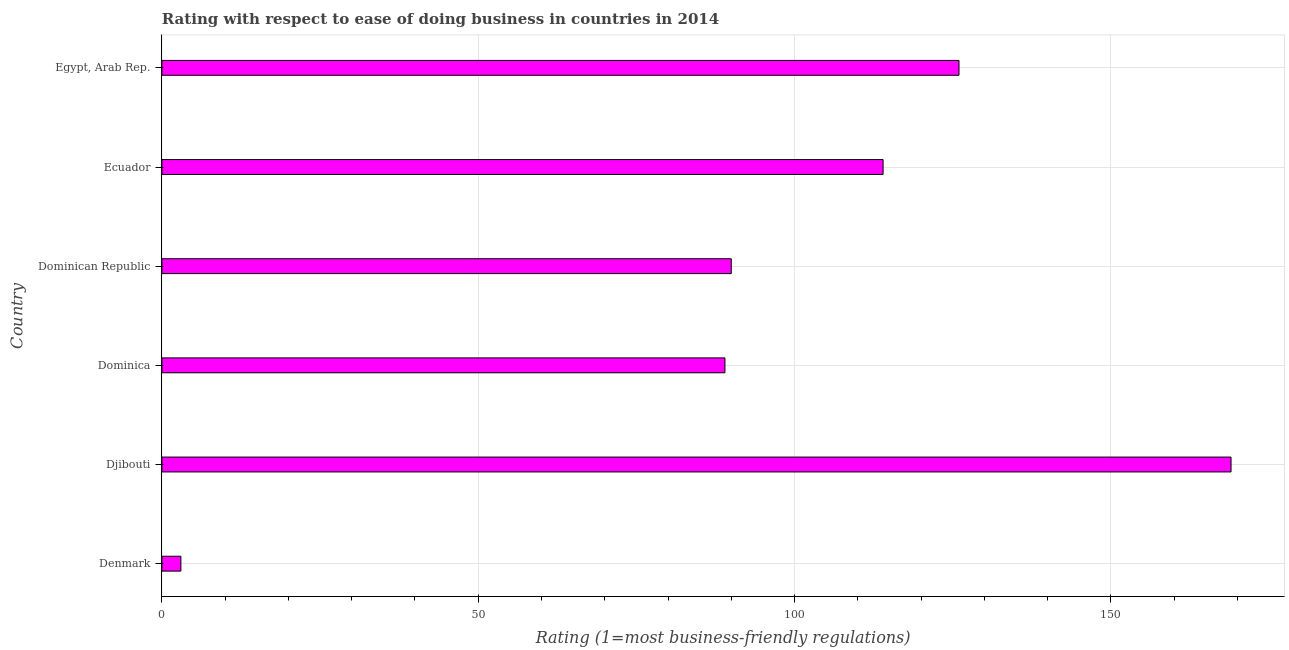Does the graph contain grids?
Your answer should be compact. Yes. What is the title of the graph?
Your answer should be very brief. Rating with respect to ease of doing business in countries in 2014. What is the label or title of the X-axis?
Your answer should be compact. Rating (1=most business-friendly regulations). What is the label or title of the Y-axis?
Offer a very short reply. Country. Across all countries, what is the maximum ease of doing business index?
Provide a succinct answer. 169. In which country was the ease of doing business index maximum?
Keep it short and to the point. Djibouti. What is the sum of the ease of doing business index?
Your answer should be compact. 591. What is the difference between the ease of doing business index in Djibouti and Dominica?
Make the answer very short. 80. What is the average ease of doing business index per country?
Ensure brevity in your answer.  98.5. What is the median ease of doing business index?
Keep it short and to the point. 102. In how many countries, is the ease of doing business index greater than 90 ?
Keep it short and to the point. 3. What is the ratio of the ease of doing business index in Denmark to that in Dominica?
Your response must be concise. 0.03. What is the difference between the highest and the second highest ease of doing business index?
Your answer should be compact. 43. Is the sum of the ease of doing business index in Djibouti and Egypt, Arab Rep. greater than the maximum ease of doing business index across all countries?
Provide a short and direct response. Yes. What is the difference between the highest and the lowest ease of doing business index?
Offer a terse response. 166. How many bars are there?
Your response must be concise. 6. Are all the bars in the graph horizontal?
Provide a succinct answer. Yes. How many countries are there in the graph?
Your response must be concise. 6. Are the values on the major ticks of X-axis written in scientific E-notation?
Your answer should be compact. No. What is the Rating (1=most business-friendly regulations) in Denmark?
Provide a short and direct response. 3. What is the Rating (1=most business-friendly regulations) of Djibouti?
Offer a very short reply. 169. What is the Rating (1=most business-friendly regulations) of Dominica?
Your answer should be compact. 89. What is the Rating (1=most business-friendly regulations) of Dominican Republic?
Your answer should be very brief. 90. What is the Rating (1=most business-friendly regulations) of Ecuador?
Your answer should be compact. 114. What is the Rating (1=most business-friendly regulations) in Egypt, Arab Rep.?
Your answer should be very brief. 126. What is the difference between the Rating (1=most business-friendly regulations) in Denmark and Djibouti?
Your response must be concise. -166. What is the difference between the Rating (1=most business-friendly regulations) in Denmark and Dominica?
Your answer should be compact. -86. What is the difference between the Rating (1=most business-friendly regulations) in Denmark and Dominican Republic?
Provide a short and direct response. -87. What is the difference between the Rating (1=most business-friendly regulations) in Denmark and Ecuador?
Keep it short and to the point. -111. What is the difference between the Rating (1=most business-friendly regulations) in Denmark and Egypt, Arab Rep.?
Provide a short and direct response. -123. What is the difference between the Rating (1=most business-friendly regulations) in Djibouti and Dominica?
Provide a short and direct response. 80. What is the difference between the Rating (1=most business-friendly regulations) in Djibouti and Dominican Republic?
Offer a very short reply. 79. What is the difference between the Rating (1=most business-friendly regulations) in Djibouti and Egypt, Arab Rep.?
Give a very brief answer. 43. What is the difference between the Rating (1=most business-friendly regulations) in Dominica and Egypt, Arab Rep.?
Ensure brevity in your answer.  -37. What is the difference between the Rating (1=most business-friendly regulations) in Dominican Republic and Egypt, Arab Rep.?
Your response must be concise. -36. What is the difference between the Rating (1=most business-friendly regulations) in Ecuador and Egypt, Arab Rep.?
Keep it short and to the point. -12. What is the ratio of the Rating (1=most business-friendly regulations) in Denmark to that in Djibouti?
Keep it short and to the point. 0.02. What is the ratio of the Rating (1=most business-friendly regulations) in Denmark to that in Dominica?
Make the answer very short. 0.03. What is the ratio of the Rating (1=most business-friendly regulations) in Denmark to that in Dominican Republic?
Offer a very short reply. 0.03. What is the ratio of the Rating (1=most business-friendly regulations) in Denmark to that in Ecuador?
Ensure brevity in your answer.  0.03. What is the ratio of the Rating (1=most business-friendly regulations) in Denmark to that in Egypt, Arab Rep.?
Provide a short and direct response. 0.02. What is the ratio of the Rating (1=most business-friendly regulations) in Djibouti to that in Dominica?
Provide a succinct answer. 1.9. What is the ratio of the Rating (1=most business-friendly regulations) in Djibouti to that in Dominican Republic?
Provide a succinct answer. 1.88. What is the ratio of the Rating (1=most business-friendly regulations) in Djibouti to that in Ecuador?
Your answer should be very brief. 1.48. What is the ratio of the Rating (1=most business-friendly regulations) in Djibouti to that in Egypt, Arab Rep.?
Offer a terse response. 1.34. What is the ratio of the Rating (1=most business-friendly regulations) in Dominica to that in Dominican Republic?
Provide a succinct answer. 0.99. What is the ratio of the Rating (1=most business-friendly regulations) in Dominica to that in Ecuador?
Provide a succinct answer. 0.78. What is the ratio of the Rating (1=most business-friendly regulations) in Dominica to that in Egypt, Arab Rep.?
Make the answer very short. 0.71. What is the ratio of the Rating (1=most business-friendly regulations) in Dominican Republic to that in Ecuador?
Your answer should be very brief. 0.79. What is the ratio of the Rating (1=most business-friendly regulations) in Dominican Republic to that in Egypt, Arab Rep.?
Offer a very short reply. 0.71. What is the ratio of the Rating (1=most business-friendly regulations) in Ecuador to that in Egypt, Arab Rep.?
Your answer should be very brief. 0.91. 